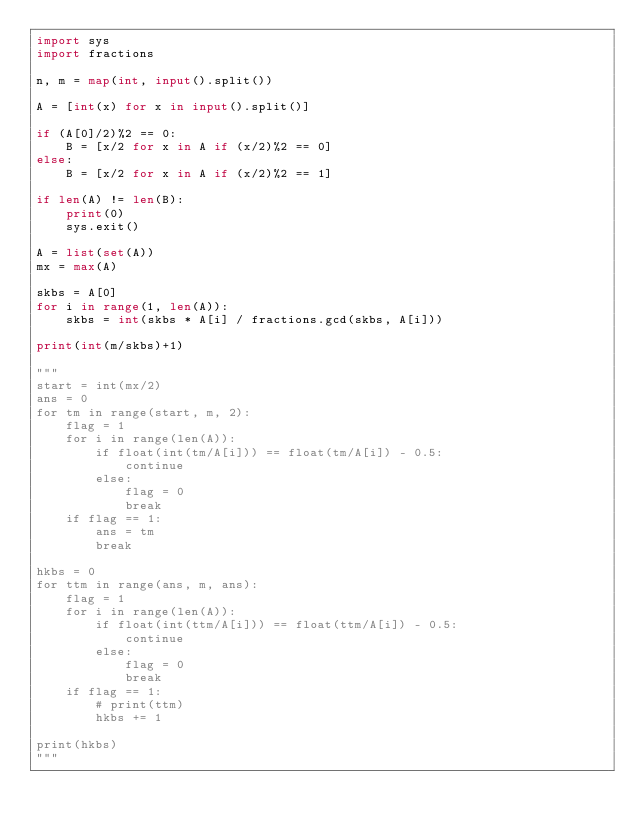Convert code to text. <code><loc_0><loc_0><loc_500><loc_500><_Python_>import sys
import fractions

n, m = map(int, input().split())

A = [int(x) for x in input().split()]

if (A[0]/2)%2 == 0:
    B = [x/2 for x in A if (x/2)%2 == 0]
else:
    B = [x/2 for x in A if (x/2)%2 == 1]

if len(A) != len(B):
    print(0)
    sys.exit()

A = list(set(A))
mx = max(A)

skbs = A[0]
for i in range(1, len(A)):
    skbs = int(skbs * A[i] / fractions.gcd(skbs, A[i]))

print(int(m/skbs)+1)

"""
start = int(mx/2)
ans = 0
for tm in range(start, m, 2):
    flag = 1
    for i in range(len(A)):
        if float(int(tm/A[i])) == float(tm/A[i]) - 0.5:
            continue
        else:
            flag = 0
            break
    if flag == 1:
        ans = tm
        break

hkbs = 0
for ttm in range(ans, m, ans):
    flag = 1
    for i in range(len(A)):
        if float(int(ttm/A[i])) == float(ttm/A[i]) - 0.5:
            continue
        else:
            flag = 0
            break
    if flag == 1:
        # print(ttm)
        hkbs += 1

print(hkbs)
"""</code> 